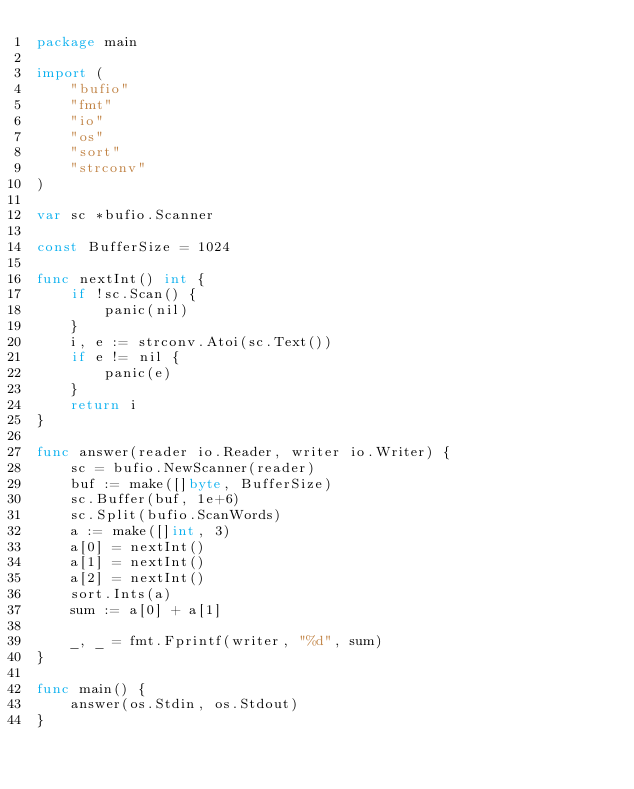Convert code to text. <code><loc_0><loc_0><loc_500><loc_500><_Go_>package main

import (
	"bufio"
	"fmt"
	"io"
	"os"
	"sort"
	"strconv"
)

var sc *bufio.Scanner

const BufferSize = 1024

func nextInt() int {
	if !sc.Scan() {
		panic(nil)
	}
	i, e := strconv.Atoi(sc.Text())
	if e != nil {
		panic(e)
	}
	return i
}

func answer(reader io.Reader, writer io.Writer) {
	sc = bufio.NewScanner(reader)
	buf := make([]byte, BufferSize)
	sc.Buffer(buf, 1e+6)
	sc.Split(bufio.ScanWords)
	a := make([]int, 3)
	a[0] = nextInt()
	a[1] = nextInt()
	a[2] = nextInt()
	sort.Ints(a)
	sum := a[0] + a[1]

	_, _ = fmt.Fprintf(writer, "%d", sum)
}

func main() {
	answer(os.Stdin, os.Stdout)
}
</code> 